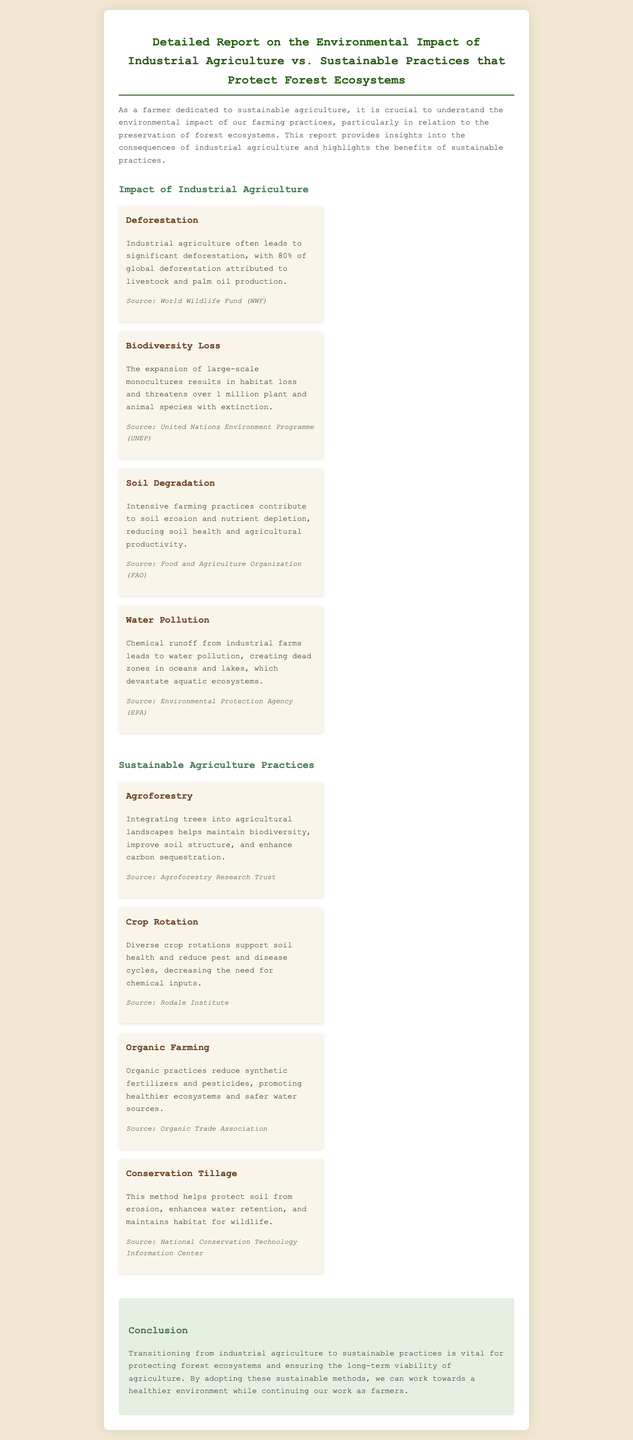What percentage of global deforestation is attributed to livestock and palm oil production? The document states that 80% of global deforestation is attributed to livestock and palm oil production.
Answer: 80% What does the loss of biodiversity threaten? According to the document, the expansion of large-scale monocultures threatens over 1 million plant and animal species with extinction.
Answer: Over 1 million plant and animal species What is one consequence of intensive farming practices mentioned in the document? The report highlights that intensive farming practices contribute to soil erosion and nutrient depletion.
Answer: Soil erosion What is a sustainable practice that helps maintain biodiversity? The letter mentions agroforestry as a practice that helps maintain biodiversity.
Answer: Agroforestry What is the impact of chemical runoff from industrial farms? The document states that chemical runoff leads to water pollution, creating dead zones in oceans and lakes.
Answer: Water pollution Why is transitioning to sustainable practices important? The conclusion emphasizes that transitioning is vital for protecting forest ecosystems and ensuring long-term viability of agriculture.
Answer: Protecting forest ecosystems What practice can reduce synthetic fertilizers and pesticides? The document specifies that organic farming practices can reduce synthetic fertilizers and pesticides.
Answer: Organic farming Which sustainable method enhances water retention? Conservation tillage is identified in the document as a method that enhances water retention.
Answer: Conservation tillage What type of document is this report classified as? This is classified as a detailed report focusing on environmental impacts and sustainable practices.
Answer: Detailed report 